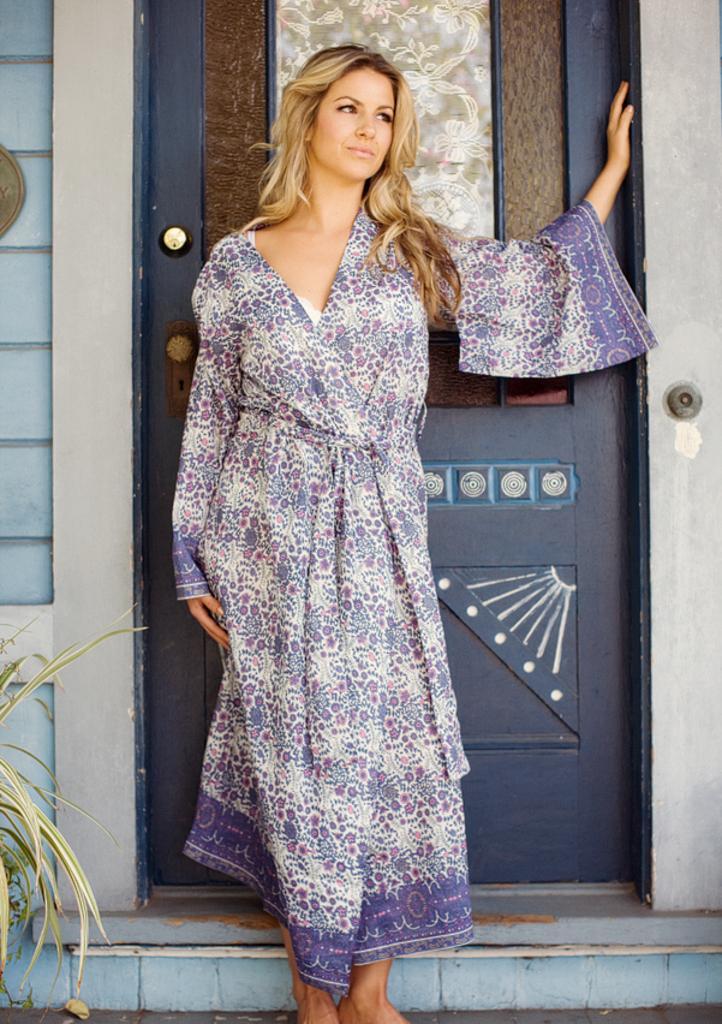Can you describe this image briefly? In this picture we can see a woman standing, leaves and at the back of her we can see the wall, door. 